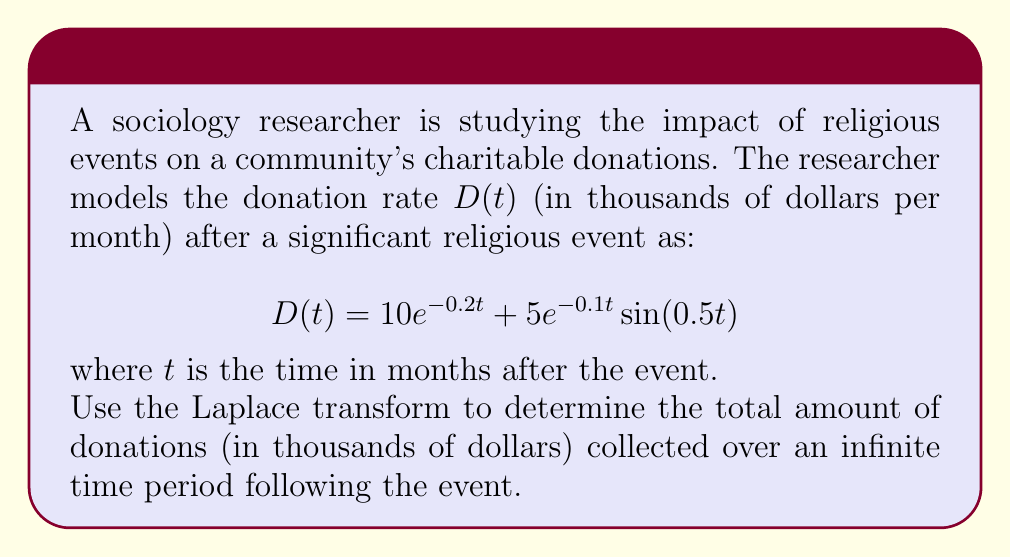Show me your answer to this math problem. To solve this problem, we'll follow these steps:

1) Recall that the Laplace transform of a function $f(t)$ is defined as:

   $$\mathcal{L}\{f(t)\} = F(s) = \int_0^\infty e^{-st}f(t)dt$$

2) The Final Value Theorem states that for a function $f(t)$ with Laplace transform $F(s)$:

   $$\lim_{t \to \infty} \int_0^t f(\tau)d\tau = \lim_{s \to 0} \frac{F(s)}{s}$$

3) This theorem allows us to find the total donations over infinite time by evaluating $\lim_{s \to 0} \frac{F(s)}{s}$.

4) First, let's find the Laplace transform of $D(t)$:

   $$\mathcal{L}\{D(t)\} = \mathcal{L}\{10e^{-0.2t}\} + \mathcal{L}\{5e^{-0.1t} \sin(0.5t)\}$$

5) Using Laplace transform properties:

   $$F(s) = \frac{10}{s+0.2} + \frac{5(0.5)}{(s+0.1)^2 + 0.5^2}$$

6) Simplify:

   $$F(s) = \frac{10}{s+0.2} + \frac{2.5}{(s+0.1)^2 + 0.25}$$

7) Now, we need to evaluate $\lim_{s \to 0} \frac{F(s)}{s}$:

   $$\lim_{s \to 0} \frac{F(s)}{s} = \lim_{s \to 0} \left(\frac{10}{s(s+0.2)} + \frac{2.5}{s((s+0.1)^2 + 0.25)}\right)$$

8) Applying L'Hôpital's rule:

   $$= \lim_{s \to 0} \left(\frac{-10}{(s+0.2)^2} - \frac{2.5(2s+0.2)}{((s+0.1)^2 + 0.25)^2}\right)$$

9) Evaluate the limit:

   $$= \frac{-10}{(0.2)^2} - \frac{2.5(0.2)}{(0.1^2 + 0.25)^2} = -250 - 5 = -255$$

10) The negative sign indicates money flowing out of the community (donations). The total amount donated is the absolute value: 255.
Answer: $255$ thousand dollars 